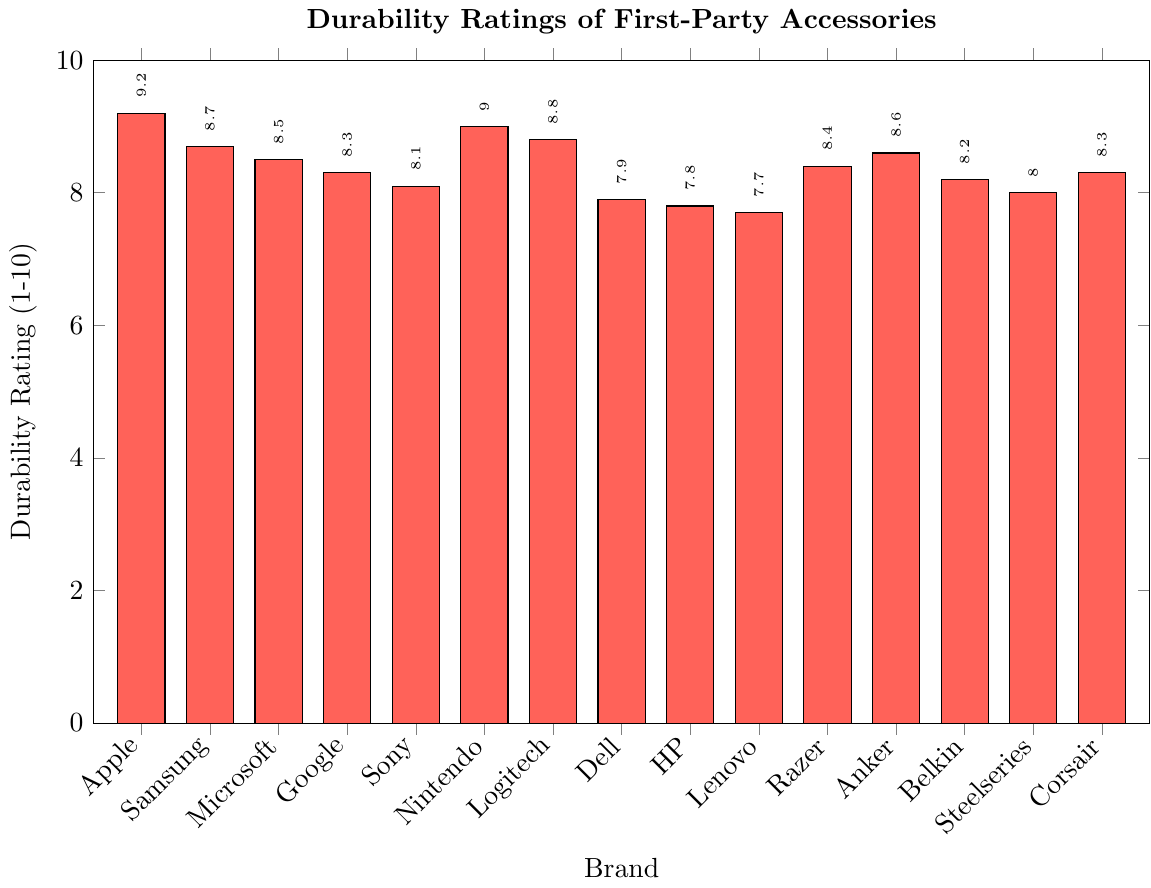What is the highest durability rating among the first-party accessories? Inspect the height of the bars on the plot. The highest bar represents Apple with a durability rating of 9.2.
Answer: 9.2 Which brand has the lowest durability rating in the plot? Look for the shortest bar on the plot. Lenovo has the lowest bar with a durability rating of 7.7.
Answer: Lenovo How much higher is the durability rating of Logitech compared to Dell? Find the bars for Logitech and Dell and subtract Dell's rating from Logitech's. Logitech is 8.8, and Dell is 7.9; thus, 8.8 - 7.9 = 0.9.
Answer: 0.9 What are the average durability ratings of Nintendo and Anker? Sum the durability ratings of Nintendo and Anker and divide by 2. Nintendo is 9.0 and Anker is 8.6; thus, (9.0 + 8.6) / 2 = 8.8.
Answer: 8.8 Are there more brands with a durability rating above 8.5 or below 8.5? Count the bars with ratings above and below 8.5. Above: Apple, Samsung, Nintendo, Logitech, Anker (5 brands). Below: Google, Sony, Dell, HP, Lenovo, Belkin, Steelseries, Corsair (8 brands).
Answer: Below How much greater is Apple's durability rating compared to HP's? Find Apple's and HP's durability ratings and subtract HP's from Apple's. Apple is 9.2 and HP is 7.8; thus, 9.2 - 7.8 = 1.4.
Answer: 1.4 What is the median durability rating among the brands? Arrange the ratings in ascending order and find the middle value. Ordered list: 7.7, 7.8, 7.9, 8.0, 8.1, 8.2, 8.3, 8.3, 8.4, 8.5, 8.6, 8.7, 8.8, 9.0, 9.2. Median is 8.3.
Answer: 8.3 Which brand has the green-colored bar, and what is its durability rating? The green-colored bar represents Microsoft with a durability rating of 8.5.
Answer: Microsoft, 8.5 What is the difference between the highest and lowest durability ratings in the plot? Subtract the lowest rating from the highest rating. Highest: Apple at 9.2, Lowest: Lenovo at 7.7; thus, 9.2 - 7.7 = 1.5.
Answer: 1.5 